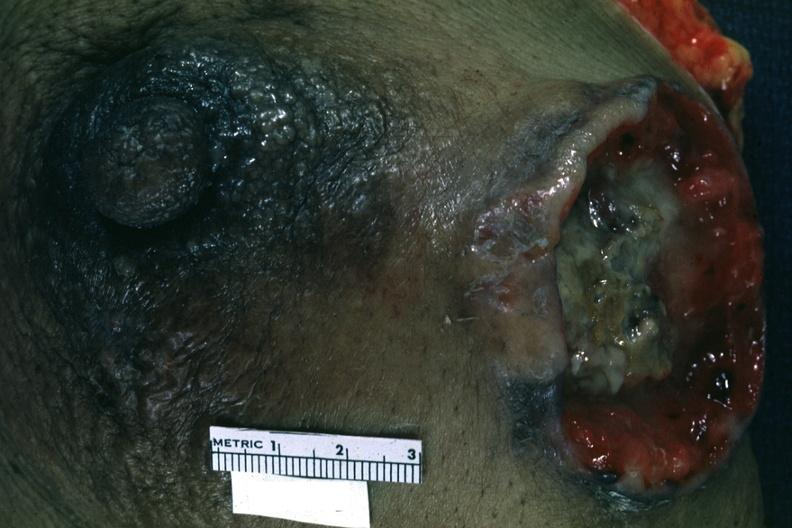what does this image show?
Answer the question using a single word or phrase. Close-up excised breast with large ulcerating carcinoma 